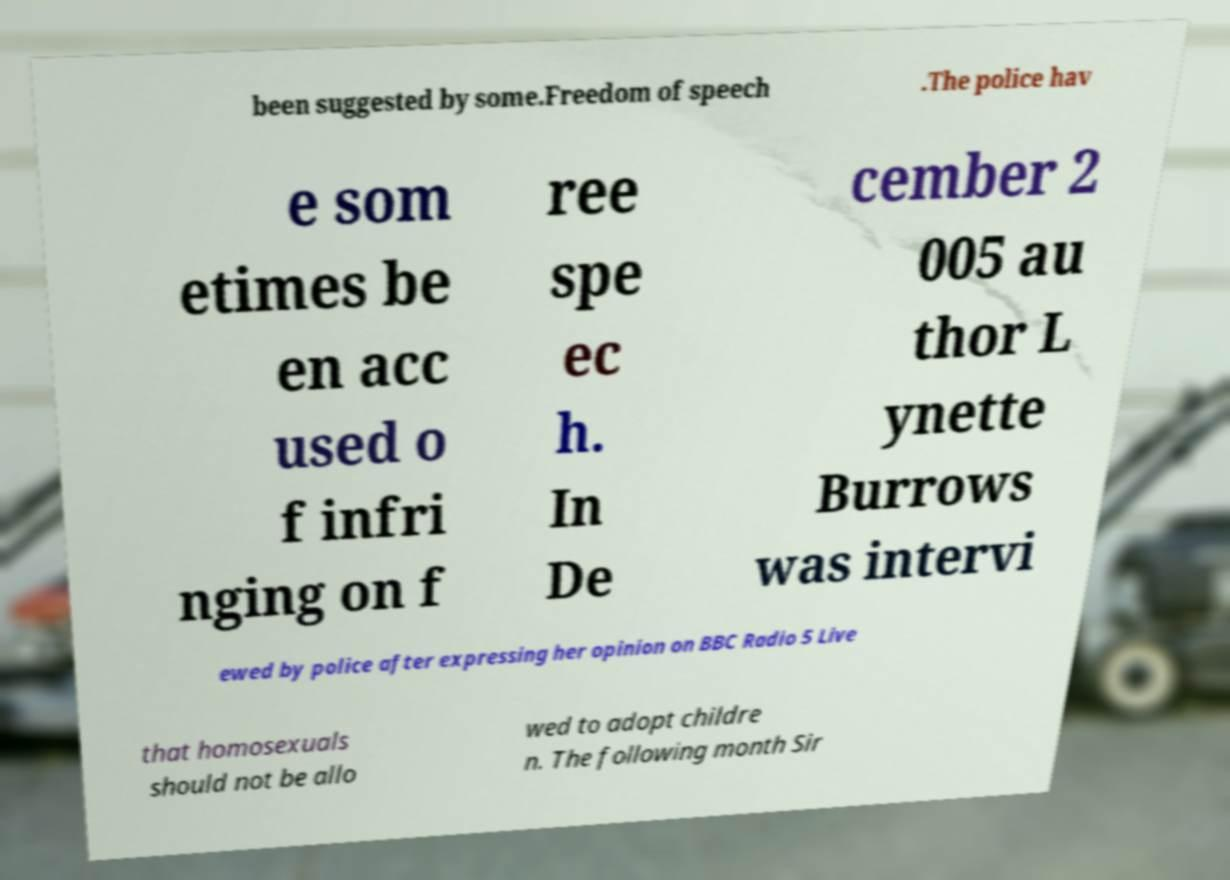Please identify and transcribe the text found in this image. been suggested by some.Freedom of speech .The police hav e som etimes be en acc used o f infri nging on f ree spe ec h. In De cember 2 005 au thor L ynette Burrows was intervi ewed by police after expressing her opinion on BBC Radio 5 Live that homosexuals should not be allo wed to adopt childre n. The following month Sir 